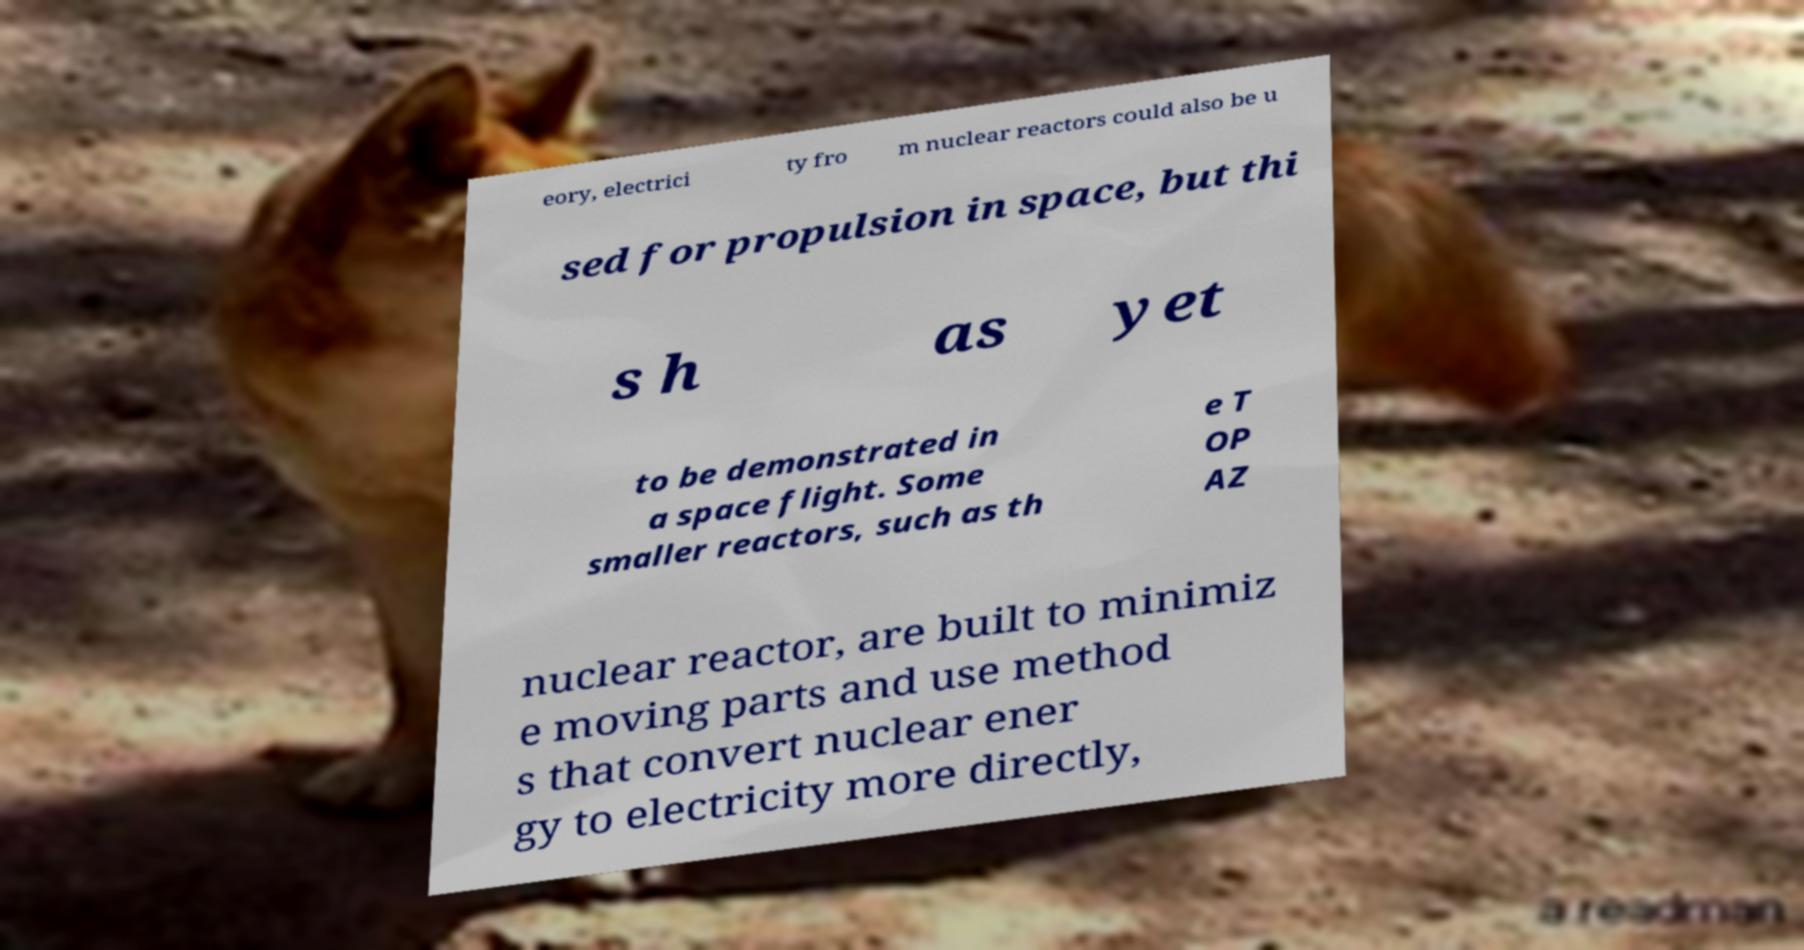Can you read and provide the text displayed in the image?This photo seems to have some interesting text. Can you extract and type it out for me? eory, electrici ty fro m nuclear reactors could also be u sed for propulsion in space, but thi s h as yet to be demonstrated in a space flight. Some smaller reactors, such as th e T OP AZ nuclear reactor, are built to minimiz e moving parts and use method s that convert nuclear ener gy to electricity more directly, 